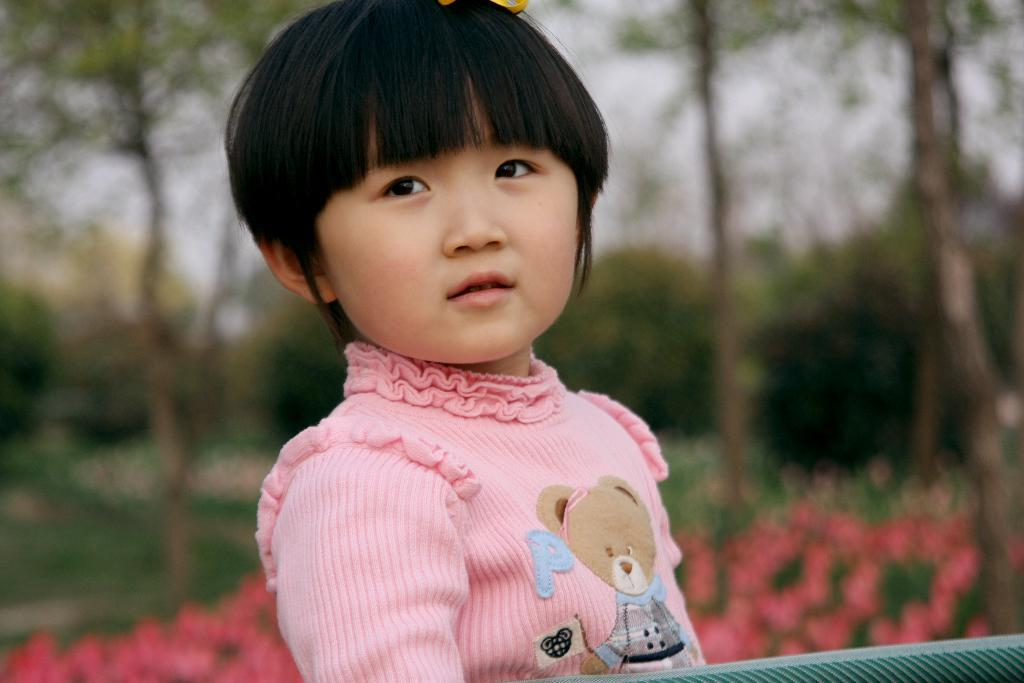What is the main subject in the front of the image? There is a kid in the front of the image. How would you describe the background of the image? The background of the image is blurred. What type of vegetation can be seen in the background? There are trees and flower plants in the background of the image. What type of yarn is being used to create the sand sculpture in the image? There is no sand sculpture or yarn present in the image. 